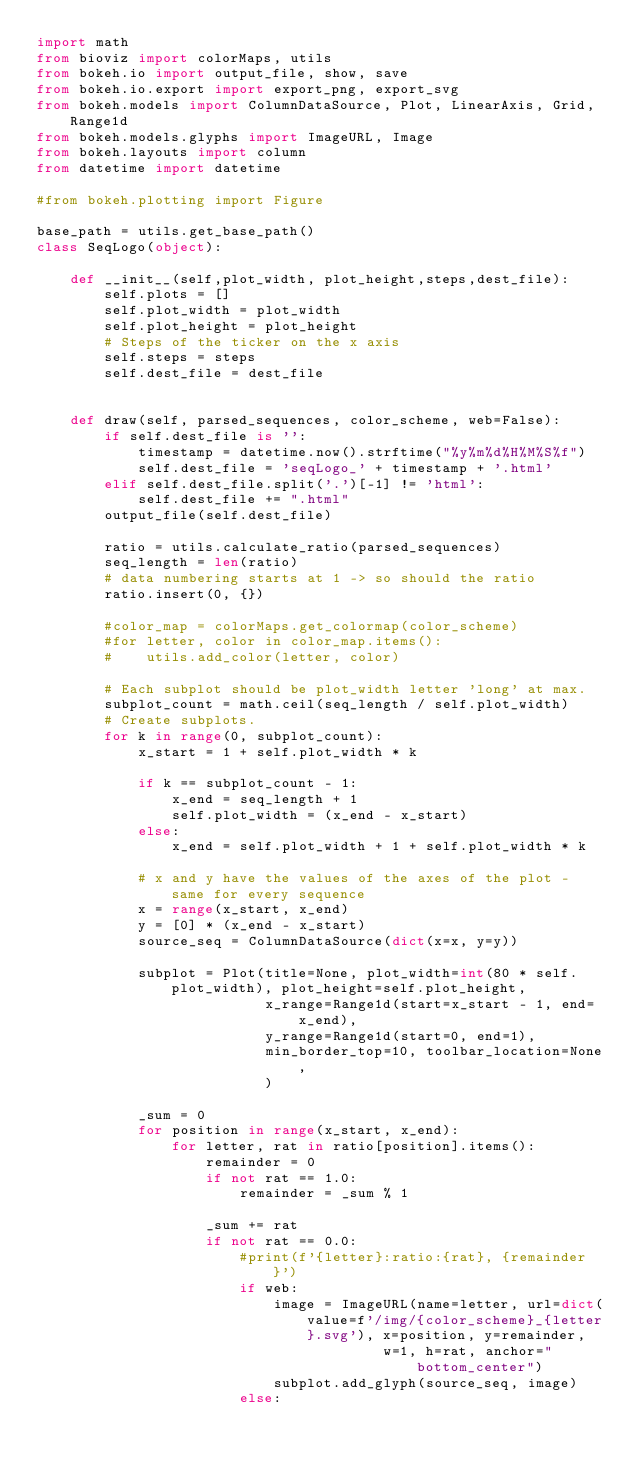Convert code to text. <code><loc_0><loc_0><loc_500><loc_500><_Python_>import math
from bioviz import colorMaps, utils
from bokeh.io import output_file, show, save
from bokeh.io.export import export_png, export_svg
from bokeh.models import ColumnDataSource, Plot, LinearAxis, Grid, Range1d
from bokeh.models.glyphs import ImageURL, Image
from bokeh.layouts import column
from datetime import datetime

#from bokeh.plotting import Figure

base_path = utils.get_base_path()
class SeqLogo(object):
    
    def __init__(self,plot_width, plot_height,steps,dest_file):
        self.plots = []
        self.plot_width = plot_width
        self.plot_height = plot_height
        # Steps of the ticker on the x axis
        self.steps = steps
        self.dest_file = dest_file


    def draw(self, parsed_sequences, color_scheme, web=False):
        if self.dest_file is '':
            timestamp = datetime.now().strftime("%y%m%d%H%M%S%f")
            self.dest_file = 'seqLogo_' + timestamp + '.html'
        elif self.dest_file.split('.')[-1] != 'html':
            self.dest_file += ".html"
        output_file(self.dest_file)

        ratio = utils.calculate_ratio(parsed_sequences)
        seq_length = len(ratio)
        # data numbering starts at 1 -> so should the ratio
        ratio.insert(0, {})

        #color_map = colorMaps.get_colormap(color_scheme)
        #for letter, color in color_map.items():
        #    utils.add_color(letter, color)

        # Each subplot should be plot_width letter 'long' at max.
        subplot_count = math.ceil(seq_length / self.plot_width)
        # Create subplots.
        for k in range(0, subplot_count):
            x_start = 1 + self.plot_width * k

            if k == subplot_count - 1:
                x_end = seq_length + 1
                self.plot_width = (x_end - x_start)
            else:
                x_end = self.plot_width + 1 + self.plot_width * k

            # x and y have the values of the axes of the plot - same for every sequence
            x = range(x_start, x_end)
            y = [0] * (x_end - x_start)
            source_seq = ColumnDataSource(dict(x=x, y=y))

            subplot = Plot(title=None, plot_width=int(80 * self.plot_width), plot_height=self.plot_height,
                           x_range=Range1d(start=x_start - 1, end=x_end),
                           y_range=Range1d(start=0, end=1),
                           min_border_top=10, toolbar_location=None,
                           )

            _sum = 0
            for position in range(x_start, x_end):
                for letter, rat in ratio[position].items():                      
                    remainder = 0
                    if not rat == 1.0:
                        remainder = _sum % 1
                        
                    _sum += rat
                    if not rat == 0.0:
                        #print(f'{letter}:ratio:{rat}, {remainder}')
                        if web:
                            image = ImageURL(name=letter, url=dict(value=f'/img/{color_scheme}_{letter}.svg'), x=position, y=remainder,
                                         w=1, h=rat, anchor="bottom_center")
                            subplot.add_glyph(source_seq, image)
                        else:</code> 